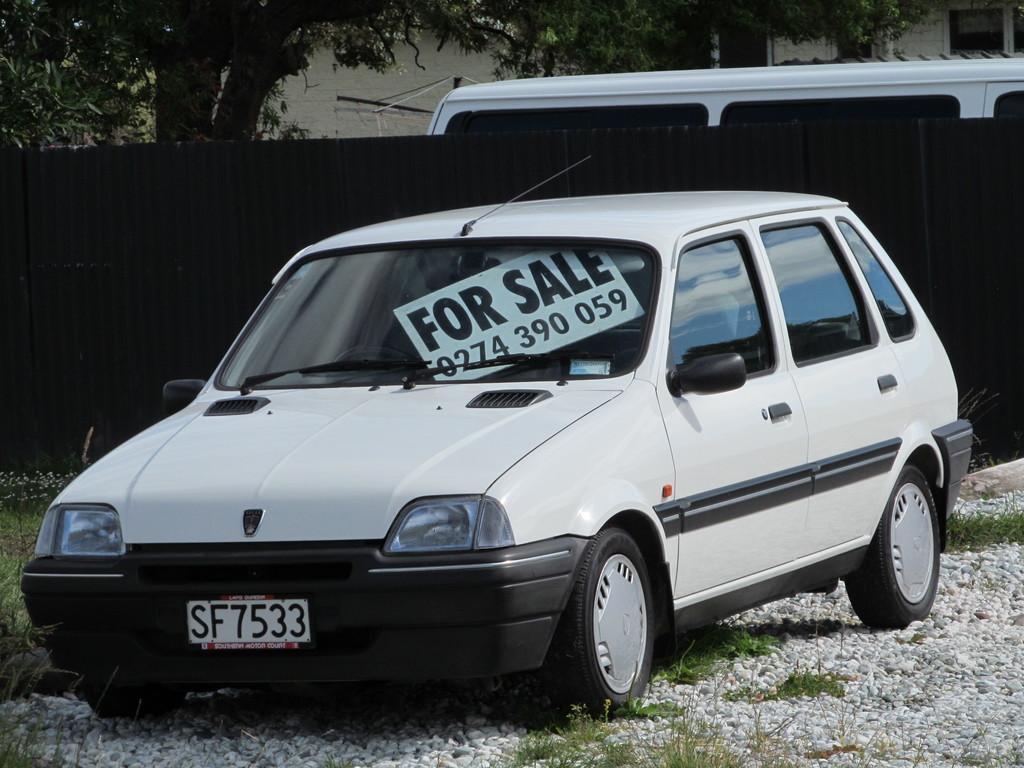Is the sign selling the car?
Provide a succinct answer. Yes. What numbers are shown on the cars license plate?
Provide a short and direct response. 7533. 